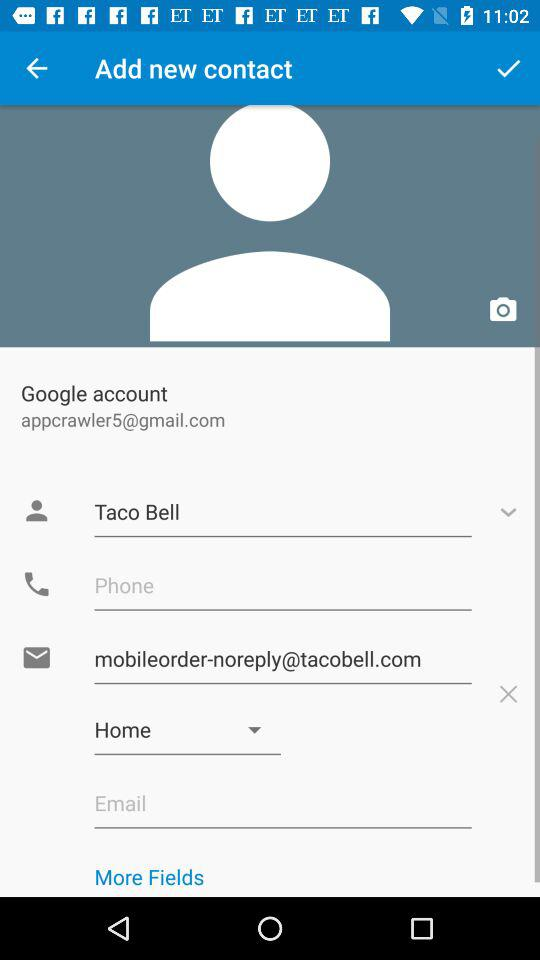Which email address is used to add the new contact? The used email address is appcrawler5@gmail.com. 